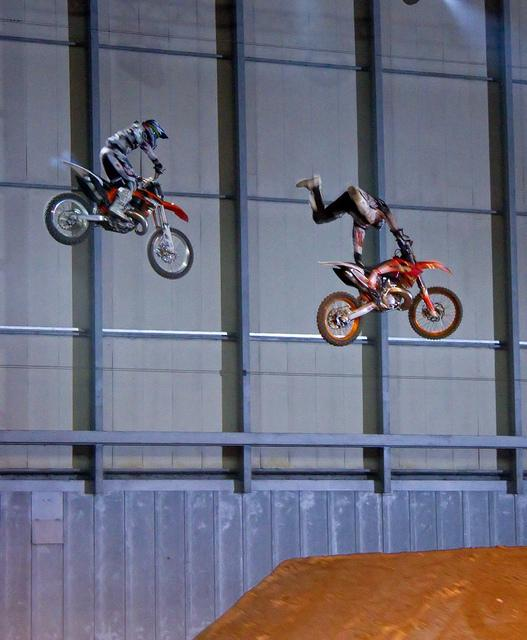What mechanism the the motorcyclists just engage?

Choices:
A) pit
B) ramp
C) flat surface
D) sand pit ramp 